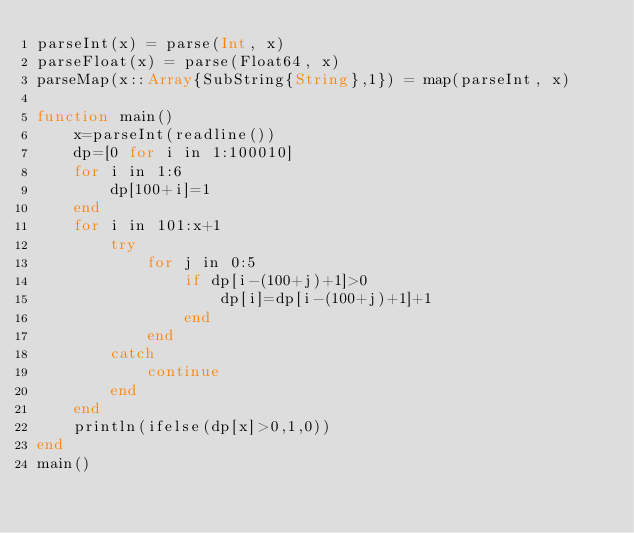Convert code to text. <code><loc_0><loc_0><loc_500><loc_500><_Julia_>parseInt(x) = parse(Int, x)
parseFloat(x) = parse(Float64, x)
parseMap(x::Array{SubString{String},1}) = map(parseInt, x)

function main()
    x=parseInt(readline())
    dp=[0 for i in 1:100010]
    for i in 1:6
        dp[100+i]=1
    end
    for i in 101:x+1
        try
            for j in 0:5
                if dp[i-(100+j)+1]>0
                    dp[i]=dp[i-(100+j)+1]+1
                end
            end
        catch
            continue
        end
    end
    println(ifelse(dp[x]>0,1,0))
end
main()</code> 